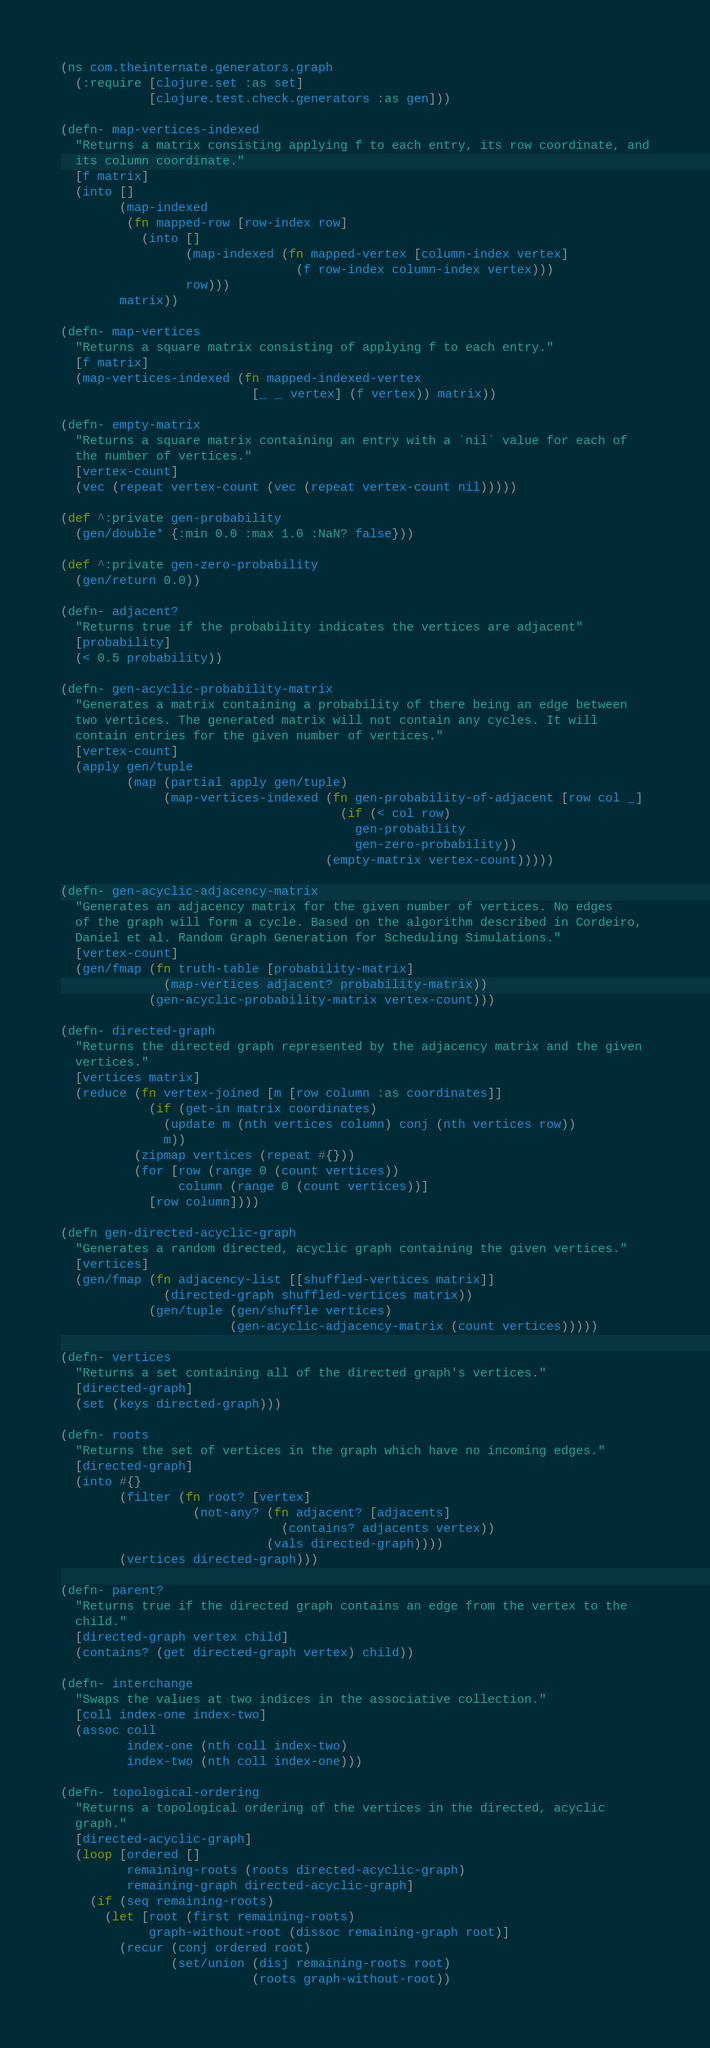<code> <loc_0><loc_0><loc_500><loc_500><_Clojure_>(ns com.theinternate.generators.graph
  (:require [clojure.set :as set]
            [clojure.test.check.generators :as gen]))

(defn- map-vertices-indexed
  "Returns a matrix consisting applying f to each entry, its row coordinate, and
  its column coordinate."
  [f matrix]
  (into []
        (map-indexed
         (fn mapped-row [row-index row]
           (into []
                 (map-indexed (fn mapped-vertex [column-index vertex]
                                (f row-index column-index vertex)))
                 row)))
        matrix))

(defn- map-vertices
  "Returns a square matrix consisting of applying f to each entry."
  [f matrix]
  (map-vertices-indexed (fn mapped-indexed-vertex
                          [_ _ vertex] (f vertex)) matrix))

(defn- empty-matrix
  "Returns a square matrix containing an entry with a `nil` value for each of
  the number of vertices."
  [vertex-count]
  (vec (repeat vertex-count (vec (repeat vertex-count nil)))))

(def ^:private gen-probability
  (gen/double* {:min 0.0 :max 1.0 :NaN? false}))

(def ^:private gen-zero-probability
  (gen/return 0.0))

(defn- adjacent?
  "Returns true if the probability indicates the vertices are adjacent"
  [probability]
  (< 0.5 probability))

(defn- gen-acyclic-probability-matrix
  "Generates a matrix containing a probability of there being an edge between
  two vertices. The generated matrix will not contain any cycles. It will
  contain entries for the given number of vertices."
  [vertex-count]
  (apply gen/tuple
         (map (partial apply gen/tuple)
              (map-vertices-indexed (fn gen-probability-of-adjacent [row col _]
                                      (if (< col row)
                                        gen-probability
                                        gen-zero-probability))
                                    (empty-matrix vertex-count)))))

(defn- gen-acyclic-adjacency-matrix
  "Generates an adjacency matrix for the given number of vertices. No edges
  of the graph will form a cycle. Based on the algorithm described in Cordeiro,
  Daniel et al. Random Graph Generation for Scheduling Simulations."
  [vertex-count]
  (gen/fmap (fn truth-table [probability-matrix]
              (map-vertices adjacent? probability-matrix))
            (gen-acyclic-probability-matrix vertex-count)))

(defn- directed-graph
  "Returns the directed graph represented by the adjacency matrix and the given
  vertices."
  [vertices matrix]
  (reduce (fn vertex-joined [m [row column :as coordinates]]
            (if (get-in matrix coordinates)
              (update m (nth vertices column) conj (nth vertices row))
              m))
          (zipmap vertices (repeat #{}))
          (for [row (range 0 (count vertices))
                column (range 0 (count vertices))]
            [row column])))

(defn gen-directed-acyclic-graph
  "Generates a random directed, acyclic graph containing the given vertices."
  [vertices]
  (gen/fmap (fn adjacency-list [[shuffled-vertices matrix]]
              (directed-graph shuffled-vertices matrix))
            (gen/tuple (gen/shuffle vertices)
                       (gen-acyclic-adjacency-matrix (count vertices)))))

(defn- vertices
  "Returns a set containing all of the directed graph's vertices."
  [directed-graph]
  (set (keys directed-graph)))

(defn- roots
  "Returns the set of vertices in the graph which have no incoming edges."
  [directed-graph]
  (into #{}
        (filter (fn root? [vertex]
                  (not-any? (fn adjacent? [adjacents]
                              (contains? adjacents vertex))
                            (vals directed-graph))))
        (vertices directed-graph)))

(defn- parent?
  "Returns true if the directed graph contains an edge from the vertex to the
  child."
  [directed-graph vertex child]
  (contains? (get directed-graph vertex) child))

(defn- interchange
  "Swaps the values at two indices in the associative collection."
  [coll index-one index-two]
  (assoc coll
         index-one (nth coll index-two)
         index-two (nth coll index-one)))

(defn- topological-ordering
  "Returns a topological ordering of the vertices in the directed, acyclic
  graph."
  [directed-acyclic-graph]
  (loop [ordered []
         remaining-roots (roots directed-acyclic-graph)
         remaining-graph directed-acyclic-graph]
    (if (seq remaining-roots)
      (let [root (first remaining-roots)
            graph-without-root (dissoc remaining-graph root)]
        (recur (conj ordered root)
               (set/union (disj remaining-roots root)
                          (roots graph-without-root))</code> 